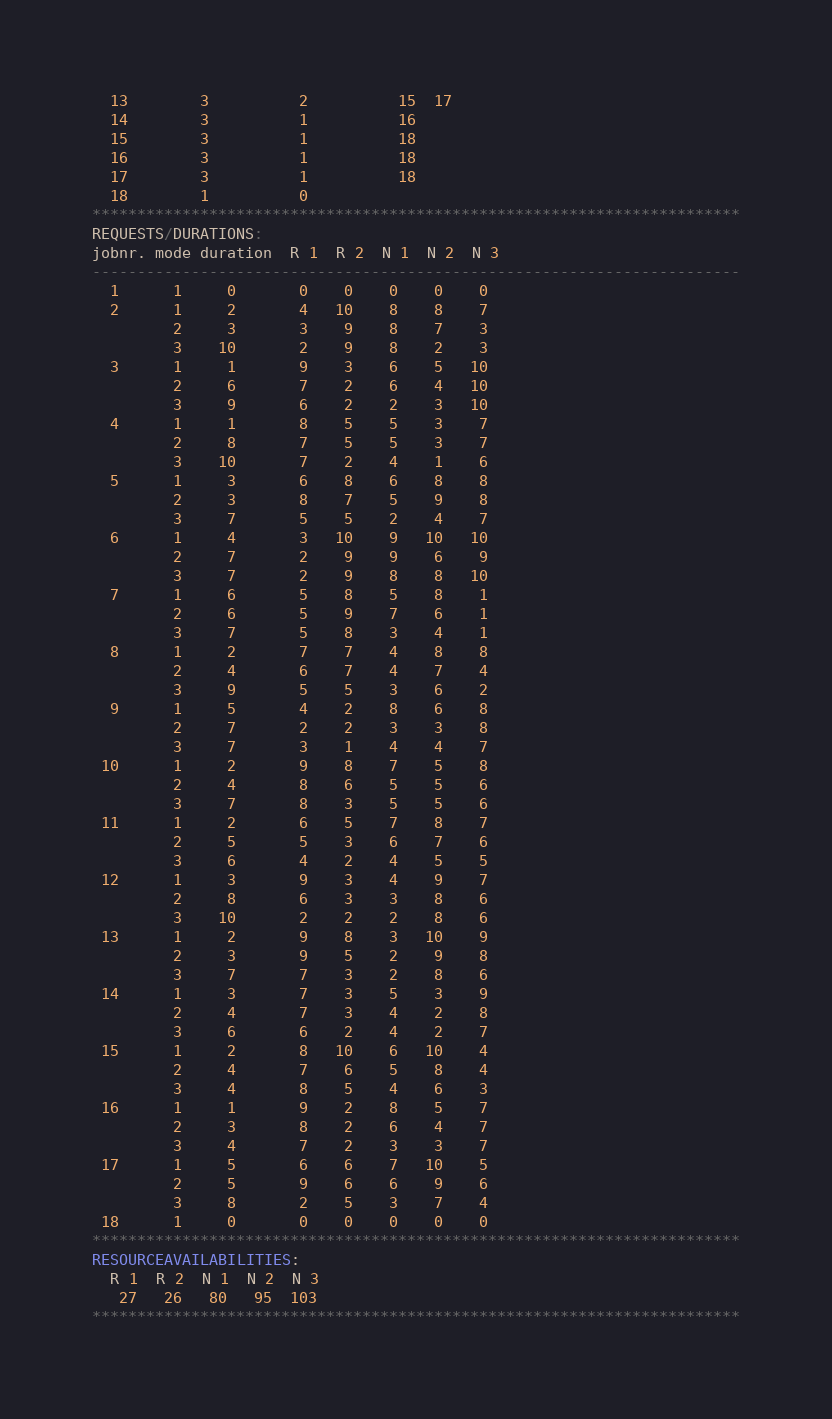Convert code to text. <code><loc_0><loc_0><loc_500><loc_500><_ObjectiveC_>  13        3          2          15  17
  14        3          1          16
  15        3          1          18
  16        3          1          18
  17        3          1          18
  18        1          0        
************************************************************************
REQUESTS/DURATIONS:
jobnr. mode duration  R 1  R 2  N 1  N 2  N 3
------------------------------------------------------------------------
  1      1     0       0    0    0    0    0
  2      1     2       4   10    8    8    7
         2     3       3    9    8    7    3
         3    10       2    9    8    2    3
  3      1     1       9    3    6    5   10
         2     6       7    2    6    4   10
         3     9       6    2    2    3   10
  4      1     1       8    5    5    3    7
         2     8       7    5    5    3    7
         3    10       7    2    4    1    6
  5      1     3       6    8    6    8    8
         2     3       8    7    5    9    8
         3     7       5    5    2    4    7
  6      1     4       3   10    9   10   10
         2     7       2    9    9    6    9
         3     7       2    9    8    8   10
  7      1     6       5    8    5    8    1
         2     6       5    9    7    6    1
         3     7       5    8    3    4    1
  8      1     2       7    7    4    8    8
         2     4       6    7    4    7    4
         3     9       5    5    3    6    2
  9      1     5       4    2    8    6    8
         2     7       2    2    3    3    8
         3     7       3    1    4    4    7
 10      1     2       9    8    7    5    8
         2     4       8    6    5    5    6
         3     7       8    3    5    5    6
 11      1     2       6    5    7    8    7
         2     5       5    3    6    7    6
         3     6       4    2    4    5    5
 12      1     3       9    3    4    9    7
         2     8       6    3    3    8    6
         3    10       2    2    2    8    6
 13      1     2       9    8    3   10    9
         2     3       9    5    2    9    8
         3     7       7    3    2    8    6
 14      1     3       7    3    5    3    9
         2     4       7    3    4    2    8
         3     6       6    2    4    2    7
 15      1     2       8   10    6   10    4
         2     4       7    6    5    8    4
         3     4       8    5    4    6    3
 16      1     1       9    2    8    5    7
         2     3       8    2    6    4    7
         3     4       7    2    3    3    7
 17      1     5       6    6    7   10    5
         2     5       9    6    6    9    6
         3     8       2    5    3    7    4
 18      1     0       0    0    0    0    0
************************************************************************
RESOURCEAVAILABILITIES:
  R 1  R 2  N 1  N 2  N 3
   27   26   80   95  103
************************************************************************
</code> 